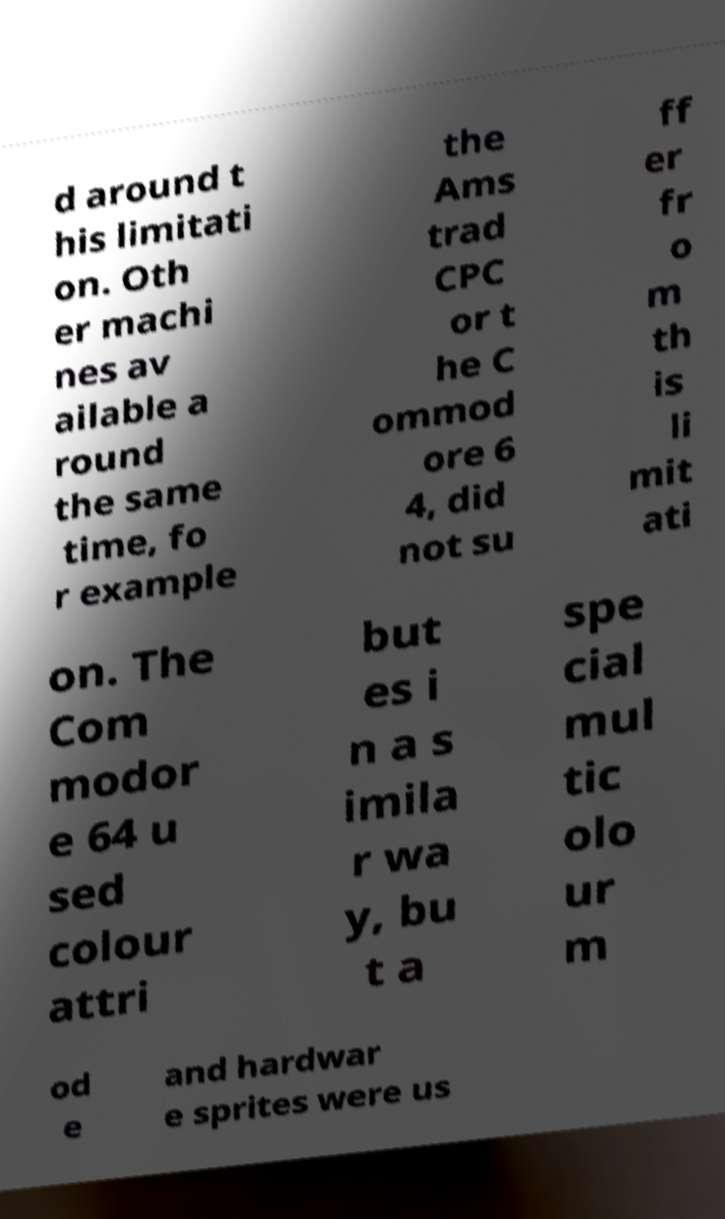What messages or text are displayed in this image? I need them in a readable, typed format. d around t his limitati on. Oth er machi nes av ailable a round the same time, fo r example the Ams trad CPC or t he C ommod ore 6 4, did not su ff er fr o m th is li mit ati on. The Com modor e 64 u sed colour attri but es i n a s imila r wa y, bu t a spe cial mul tic olo ur m od e and hardwar e sprites were us 